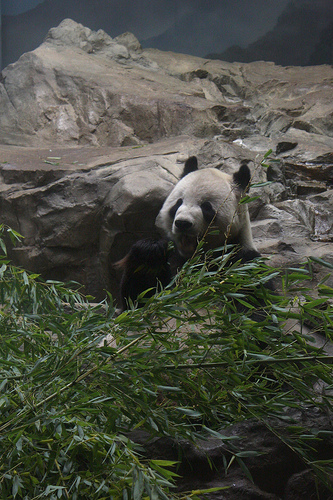<image>
Is the panda behind the bamboo? Yes. From this viewpoint, the panda is positioned behind the bamboo, with the bamboo partially or fully occluding the panda. 